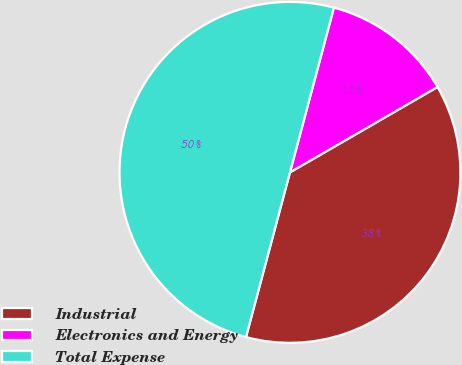Convert chart. <chart><loc_0><loc_0><loc_500><loc_500><pie_chart><fcel>Industrial<fcel>Electronics and Energy<fcel>Total Expense<nl><fcel>37.5%<fcel>12.5%<fcel>50.0%<nl></chart> 